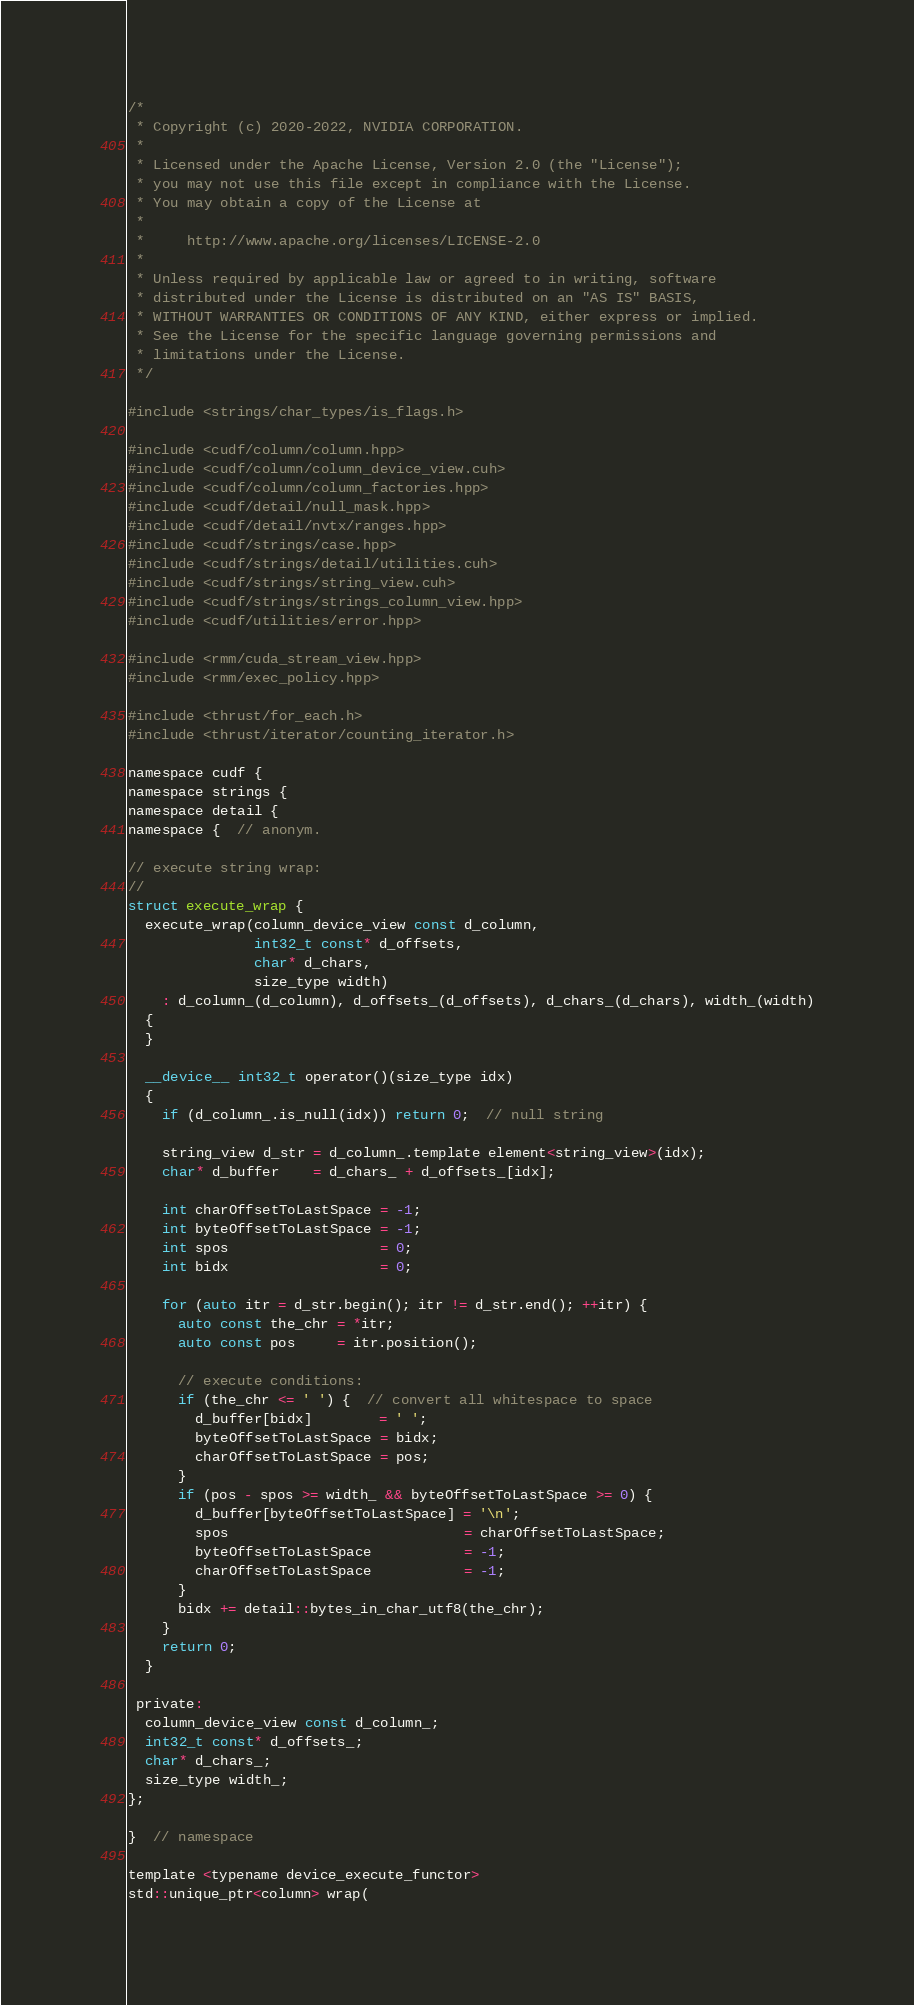Convert code to text. <code><loc_0><loc_0><loc_500><loc_500><_Cuda_>/*
 * Copyright (c) 2020-2022, NVIDIA CORPORATION.
 *
 * Licensed under the Apache License, Version 2.0 (the "License");
 * you may not use this file except in compliance with the License.
 * You may obtain a copy of the License at
 *
 *     http://www.apache.org/licenses/LICENSE-2.0
 *
 * Unless required by applicable law or agreed to in writing, software
 * distributed under the License is distributed on an "AS IS" BASIS,
 * WITHOUT WARRANTIES OR CONDITIONS OF ANY KIND, either express or implied.
 * See the License for the specific language governing permissions and
 * limitations under the License.
 */

#include <strings/char_types/is_flags.h>

#include <cudf/column/column.hpp>
#include <cudf/column/column_device_view.cuh>
#include <cudf/column/column_factories.hpp>
#include <cudf/detail/null_mask.hpp>
#include <cudf/detail/nvtx/ranges.hpp>
#include <cudf/strings/case.hpp>
#include <cudf/strings/detail/utilities.cuh>
#include <cudf/strings/string_view.cuh>
#include <cudf/strings/strings_column_view.hpp>
#include <cudf/utilities/error.hpp>

#include <rmm/cuda_stream_view.hpp>
#include <rmm/exec_policy.hpp>

#include <thrust/for_each.h>
#include <thrust/iterator/counting_iterator.h>

namespace cudf {
namespace strings {
namespace detail {
namespace {  // anonym.

// execute string wrap:
//
struct execute_wrap {
  execute_wrap(column_device_view const d_column,
               int32_t const* d_offsets,
               char* d_chars,
               size_type width)
    : d_column_(d_column), d_offsets_(d_offsets), d_chars_(d_chars), width_(width)
  {
  }

  __device__ int32_t operator()(size_type idx)
  {
    if (d_column_.is_null(idx)) return 0;  // null string

    string_view d_str = d_column_.template element<string_view>(idx);
    char* d_buffer    = d_chars_ + d_offsets_[idx];

    int charOffsetToLastSpace = -1;
    int byteOffsetToLastSpace = -1;
    int spos                  = 0;
    int bidx                  = 0;

    for (auto itr = d_str.begin(); itr != d_str.end(); ++itr) {
      auto const the_chr = *itr;
      auto const pos     = itr.position();

      // execute conditions:
      if (the_chr <= ' ') {  // convert all whitespace to space
        d_buffer[bidx]        = ' ';
        byteOffsetToLastSpace = bidx;
        charOffsetToLastSpace = pos;
      }
      if (pos - spos >= width_ && byteOffsetToLastSpace >= 0) {
        d_buffer[byteOffsetToLastSpace] = '\n';
        spos                            = charOffsetToLastSpace;
        byteOffsetToLastSpace           = -1;
        charOffsetToLastSpace           = -1;
      }
      bidx += detail::bytes_in_char_utf8(the_chr);
    }
    return 0;
  }

 private:
  column_device_view const d_column_;
  int32_t const* d_offsets_;
  char* d_chars_;
  size_type width_;
};

}  // namespace

template <typename device_execute_functor>
std::unique_ptr<column> wrap(</code> 